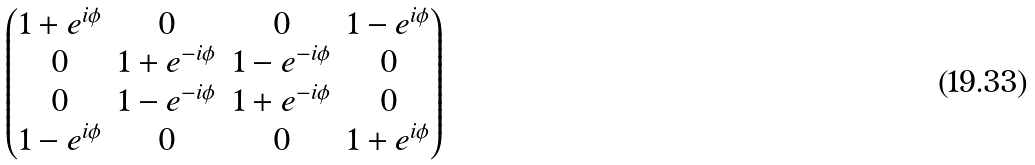<formula> <loc_0><loc_0><loc_500><loc_500>\begin{pmatrix} 1 + e ^ { i \phi } & 0 & 0 & 1 - e ^ { i \phi } \\ 0 & 1 + e ^ { - i \phi } & 1 - e ^ { - i \phi } & 0 \\ 0 & 1 - e ^ { - i \phi } & 1 + e ^ { - i \phi } & 0 \\ 1 - e ^ { i \phi } & 0 & 0 & 1 + e ^ { i \phi } \\ \end{pmatrix}</formula> 